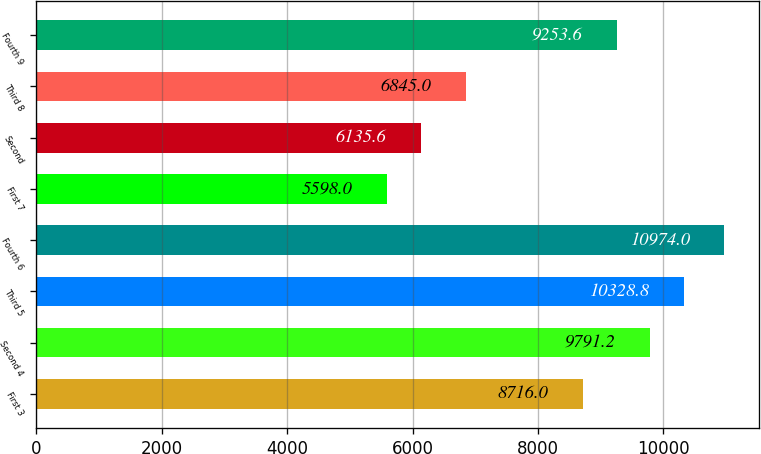<chart> <loc_0><loc_0><loc_500><loc_500><bar_chart><fcel>First 3<fcel>Second 4<fcel>Third 5<fcel>Fourth 6<fcel>First 7<fcel>Second<fcel>Third 8<fcel>Fourth 9<nl><fcel>8716<fcel>9791.2<fcel>10328.8<fcel>10974<fcel>5598<fcel>6135.6<fcel>6845<fcel>9253.6<nl></chart> 